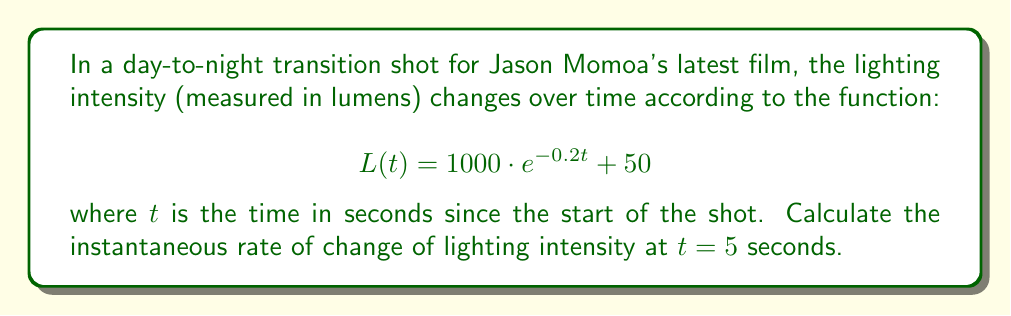Show me your answer to this math problem. To find the instantaneous rate of change of lighting intensity at $t = 5$ seconds, we need to calculate the derivative of the function $L(t)$ and evaluate it at $t = 5$.

1. First, let's find the derivative of $L(t)$:
   
   $$\frac{d}{dt}[L(t)] = \frac{d}{dt}[1000 \cdot e^{-0.2t} + 50]$$
   
   Using the chain rule, we get:
   
   $$L'(t) = 1000 \cdot (-0.2) \cdot e^{-0.2t} + 0$$
   
   $$L'(t) = -200 \cdot e^{-0.2t}$$

2. Now, we evaluate $L'(t)$ at $t = 5$:
   
   $$L'(5) = -200 \cdot e^{-0.2(5)}$$
   
   $$L'(5) = -200 \cdot e^{-1}$$

3. Calculate the final value:
   
   $$L'(5) = -200 \cdot (1/e) \approx -73.58$$

The negative value indicates that the lighting intensity is decreasing at this point in time.
Answer: The instantaneous rate of change of lighting intensity at $t = 5$ seconds is approximately $-73.58$ lumens per second. 